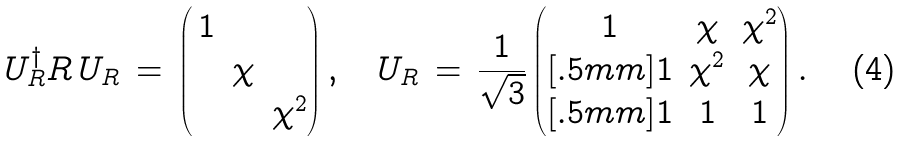<formula> <loc_0><loc_0><loc_500><loc_500>U _ { R } ^ { \dagger } R \, U _ { R } \, = \, \begin{pmatrix} \, 1 & & \\ & \chi & \\ & & \chi ^ { 2 } \end{pmatrix} , \quad U _ { R } \, = \, \frac { 1 } { \sqrt { 3 } } \begin{pmatrix} 1 & \chi & \chi ^ { 2 } \\ [ . 5 m m ] 1 & \chi ^ { 2 } & \chi \\ [ . 5 m m ] 1 & 1 & 1 \end{pmatrix} .</formula> 